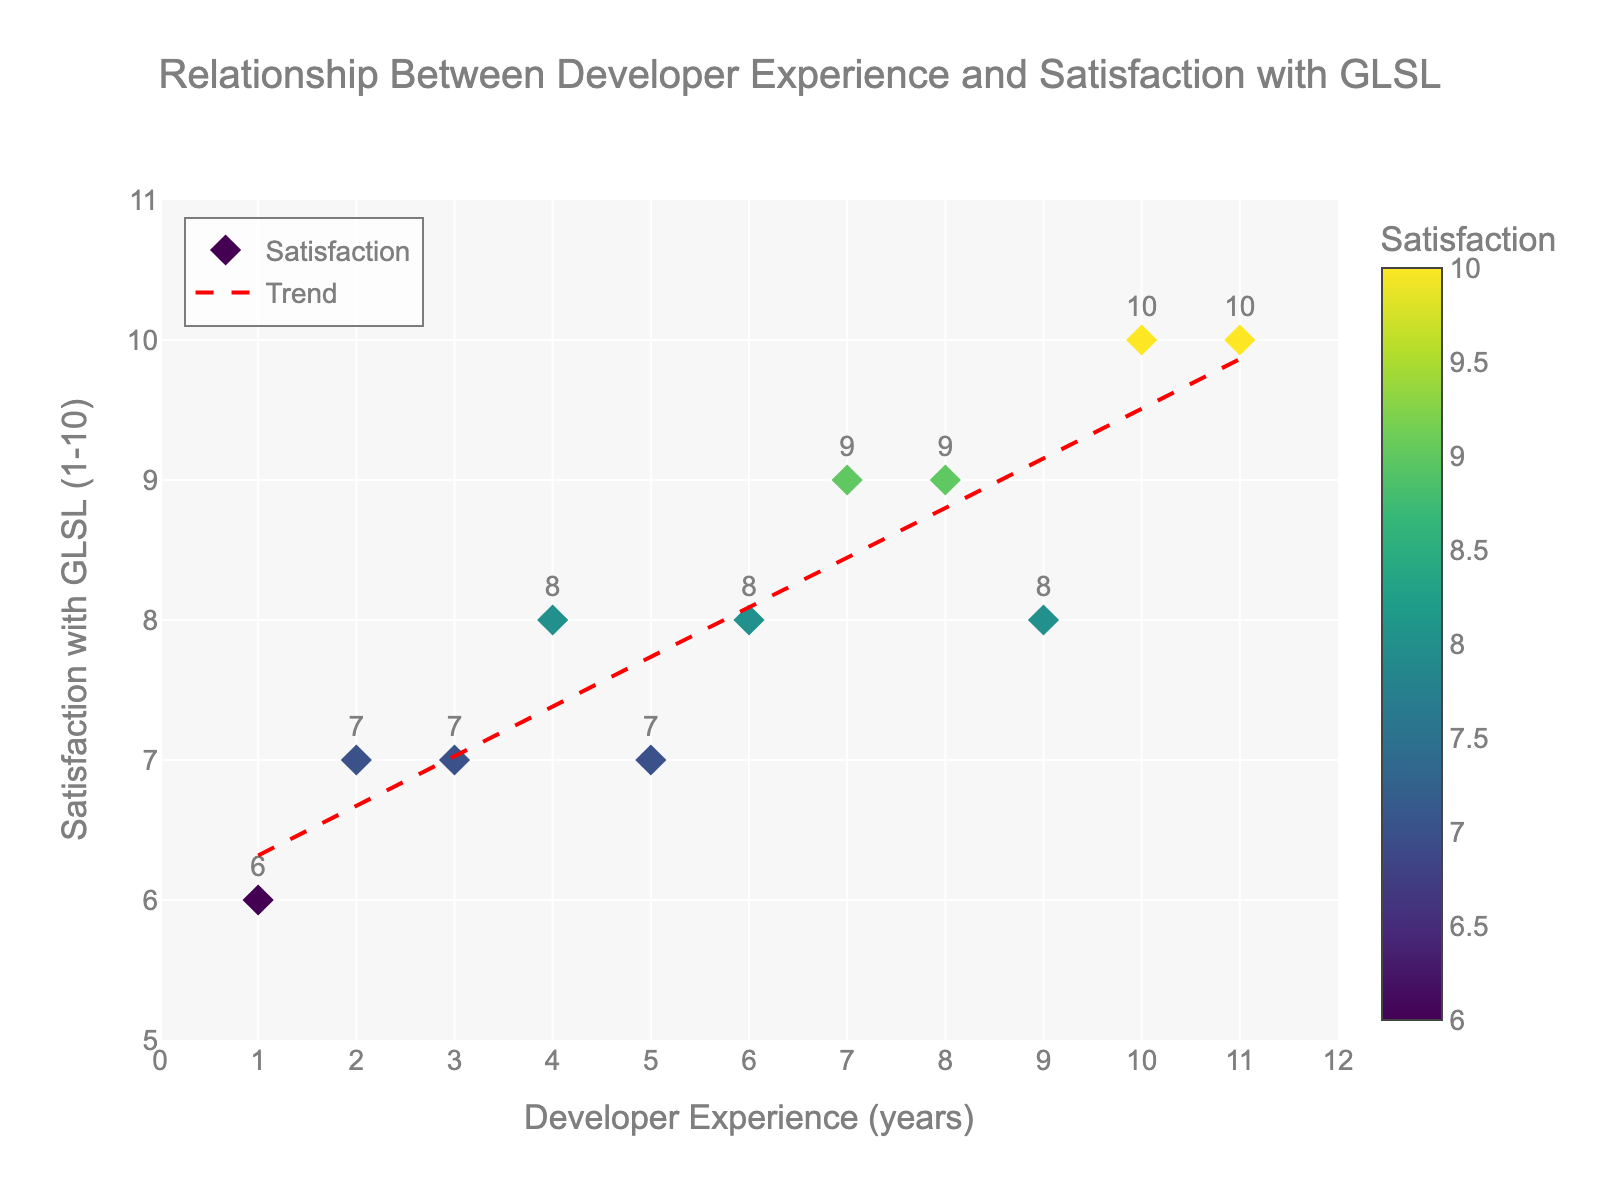What is the title of the scatter plot? The title of the scatter plot is located at the top center of the figure, inside the layout.
Answer: Relationship Between Developer Experience and Satisfaction with GLSL How many data points are shown in the scatter plot? By examining the number of markers on the scatter plot, we can count that there are eleven markers corresponding to the data points.
Answer: 11 What is the satisfaction score for a developer with 7 years of experience? Locate the marker corresponding to 7 years of experience on the x-axis and read the associated satisfaction score. The text above the marker shows a score of 9.
Answer: 9 What is the range of the x-axis (Developer Experience)? The x-axis range is set and can be observed by the minimum and maximum values on the axis scale. The figure shows a range from 0 to 12 years.
Answer: 0 to 12 How does satisfaction with GLSL trend as developer experience increases? Observe the trend line in red; it has a positive slope indicating that as developer experience increases, satisfaction with GLSL also increases.
Answer: Increases What is the overall trend in the scatter plot? By looking at the red dashed trend line fitted to the scatter plot, we see that it represents an upward trend indicating a positive relationship between developer experience and satisfaction.
Answer: Positive relationship Which developer experience level has the highest satisfaction score? Identify the highest point on the y-axis, which is the satisfaction score (10), and check the corresponding developer experience on the x-axis, which is at 10 and 11 years.
Answer: 10 and 11 years Are there any developers with a satisfaction score below 6? By examining the y-axis and the markers, we can see that all satisfaction scores are 6 or above. Therefore, no developers have a score below 6.
Answer: No What is the average satisfaction for developers with 1 to 5 years of experience? Sum the satisfaction scores (6+7+7+8+7) for developers with 1 to 5 years of experience, which is 35. Then divide it by 5 (the number of data points) to get an average satisfaction score.
Answer: 7 Does the color of the markers indicate anything? The color of the markers follows the Viridis colorscale and corresponds to the satisfaction scores, acting as a visual indicator for satisfaction levels.
Answer: Yes, it indicates satisfaction levels 